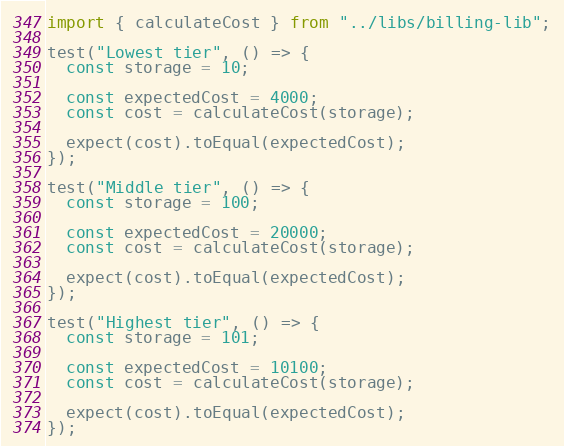<code> <loc_0><loc_0><loc_500><loc_500><_JavaScript_>import { calculateCost } from "../libs/billing-lib";

test("Lowest tier", () => {
  const storage = 10;

  const expectedCost = 4000;
  const cost = calculateCost(storage);

  expect(cost).toEqual(expectedCost);
});

test("Middle tier", () => {
  const storage = 100;

  const expectedCost = 20000;
  const cost = calculateCost(storage);

  expect(cost).toEqual(expectedCost);
});

test("Highest tier", () => {
  const storage = 101;

  const expectedCost = 10100;
  const cost = calculateCost(storage);

  expect(cost).toEqual(expectedCost);
});
</code> 